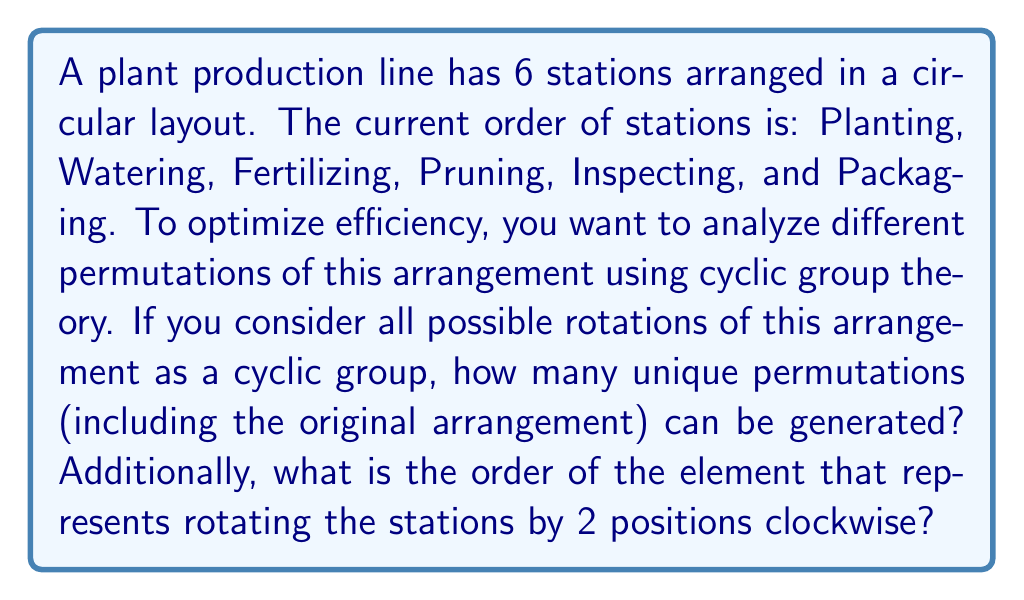Could you help me with this problem? Let's approach this step-by-step using concepts from cyclic group theory:

1) First, we need to understand that we're dealing with a cyclic group of order 6, which we can call $C_6$. This group represents all rotations of the 6 stations.

2) In a cyclic group, the number of unique permutations is equal to the order of the group. This is because each rotation generates a unique arrangement until we return to the original position.

3) Therefore, the number of unique permutations is 6.

4) Now, let's consider the rotation by 2 positions clockwise. We can represent this as an element $r$ in our group $C_6$.

5) To find the order of $r$, we need to determine the smallest positive integer $n$ such that $r^n = e$ (the identity element).

6) Let's see what happens when we apply $r$ multiple times:
   $r^1$: rotate by 2 positions
   $r^2$: rotate by 4 positions
   $r^3$: rotate by 6 positions (back to the original arrangement)

7) We see that $r^3 = e$, and 3 is the smallest positive integer that satisfies this.

Therefore, the order of the element $r$ (rotation by 2 positions) is 3.
Answer: The number of unique permutations is 6, and the order of the element representing rotation by 2 positions is 3. 